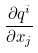Convert formula to latex. <formula><loc_0><loc_0><loc_500><loc_500>\frac { \partial q ^ { i } } { \partial x _ { j } }</formula> 